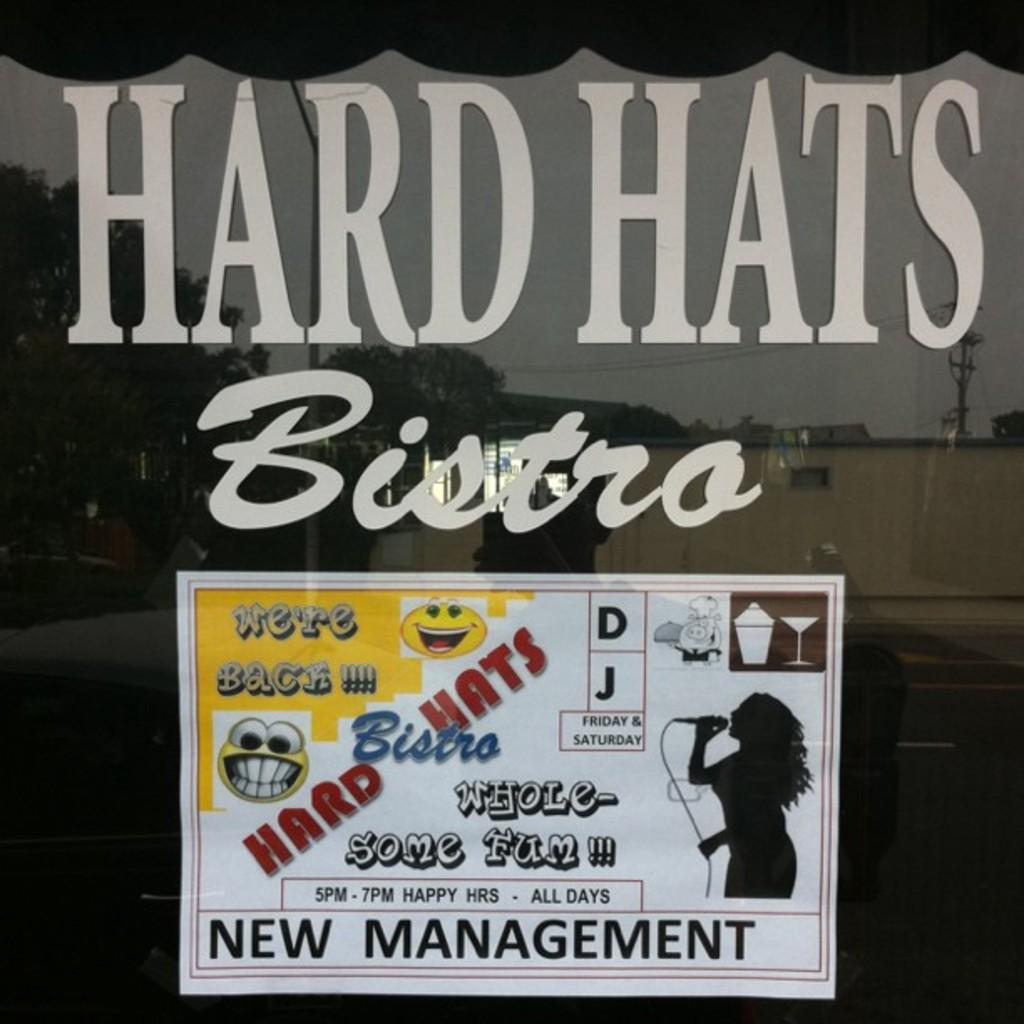What object is present in the image that can hold a liquid? There is a glass in the image that can hold a liquid. What is covering the glass in the image? There is a poster pasted on the glass. What can be read on the poster? There is text on the poster. What type of patch is sewn onto the glass in the image? There is no patch sewn onto the glass in the image; it has a poster pasted on it. 